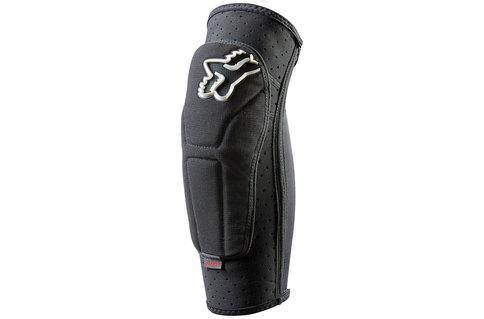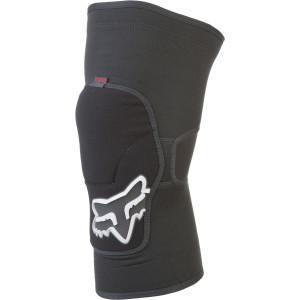The first image is the image on the left, the second image is the image on the right. For the images displayed, is the sentence "There are two knee pads that are primarily black in color" factually correct? Answer yes or no. Yes. 